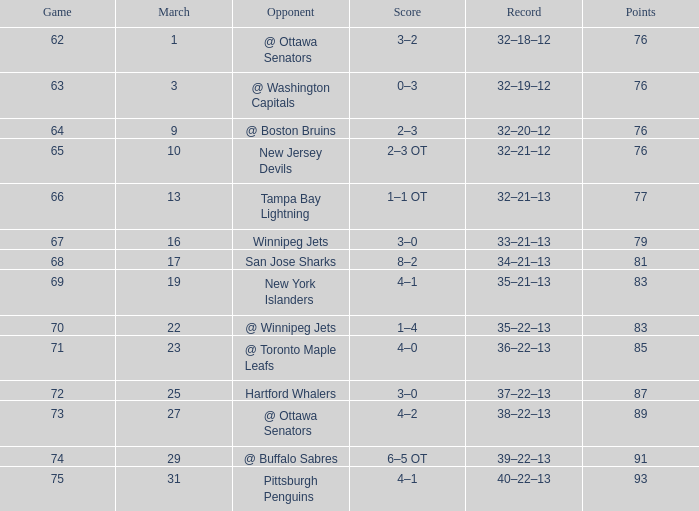What is the total number of 85 points in march? 1.0. 